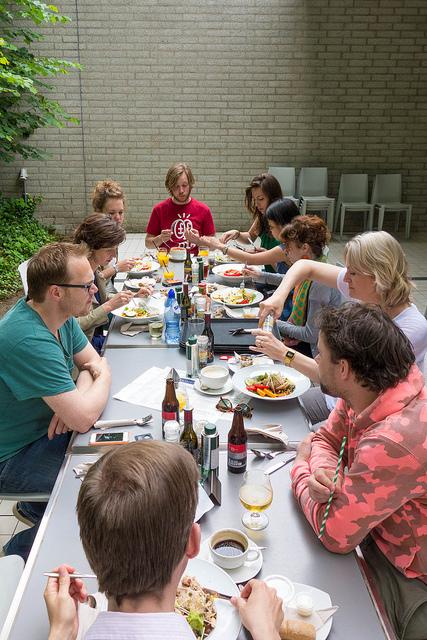Could this be a family?
Short answer required. Yes. Is the group of people above a complete familial unit engaged in an activity?
Quick response, please. Yes. How many men are there?
Quick response, please. 5. 